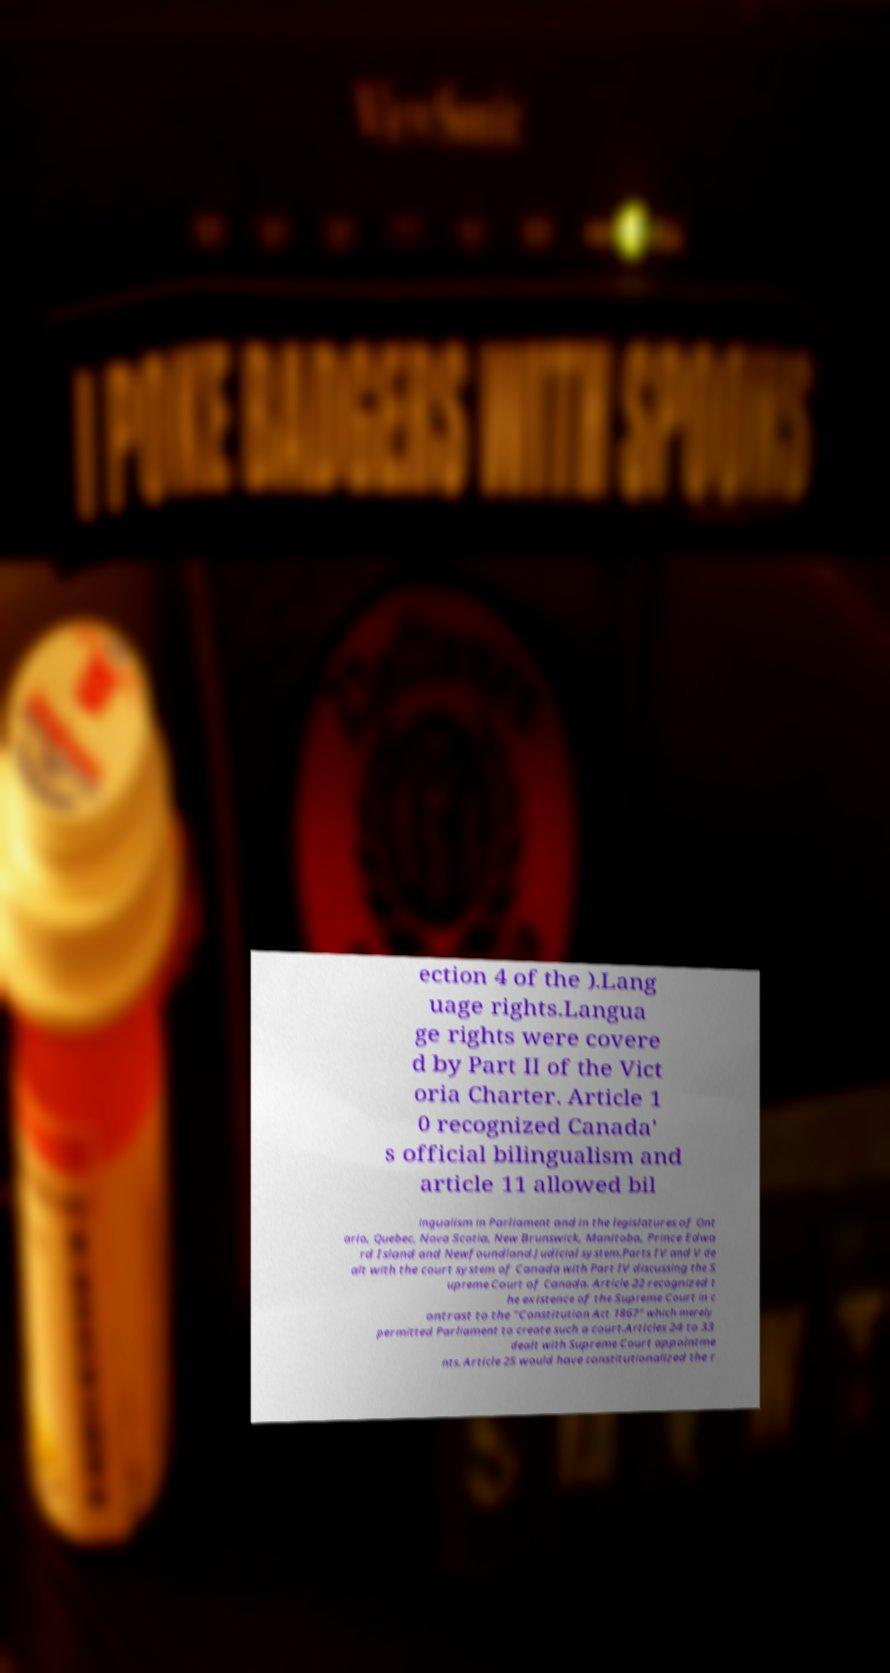Please identify and transcribe the text found in this image. ection 4 of the ).Lang uage rights.Langua ge rights were covere d by Part II of the Vict oria Charter. Article 1 0 recognized Canada' s official bilingualism and article 11 allowed bil ingualism in Parliament and in the legislatures of Ont ario, Quebec, Nova Scotia, New Brunswick, Manitoba, Prince Edwa rd Island and Newfoundland.Judicial system.Parts IV and V de alt with the court system of Canada with Part IV discussing the S upreme Court of Canada. Article 22 recognized t he existence of the Supreme Court in c ontrast to the "Constitution Act 1867" which merely permitted Parliament to create such a court.Articles 24 to 33 dealt with Supreme Court appointme nts. Article 25 would have constitutionalized the r 